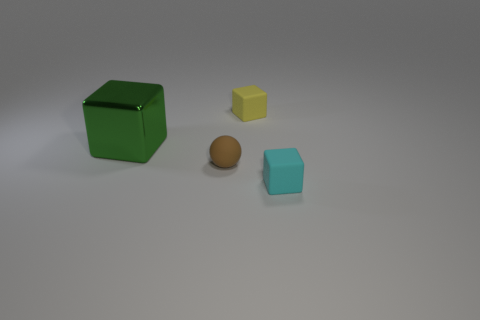Subtract all small cubes. How many cubes are left? 1 Add 2 big cyan balls. How many objects exist? 6 Subtract all cubes. How many objects are left? 1 Subtract all red cubes. Subtract all green spheres. How many cubes are left? 3 Add 4 cyan cubes. How many cyan cubes are left? 5 Add 1 brown cubes. How many brown cubes exist? 1 Subtract 0 gray blocks. How many objects are left? 4 Subtract all small brown matte spheres. Subtract all brown matte things. How many objects are left? 2 